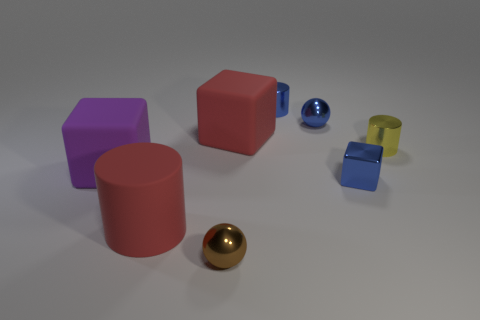Subtract all small blue cylinders. How many cylinders are left? 2 Subtract 1 cylinders. How many cylinders are left? 2 Add 2 small brown metal things. How many objects exist? 10 Subtract all balls. How many objects are left? 6 Add 5 green metal blocks. How many green metal blocks exist? 5 Subtract 0 green balls. How many objects are left? 8 Subtract all big red rubber cylinders. Subtract all shiny objects. How many objects are left? 2 Add 3 matte objects. How many matte objects are left? 6 